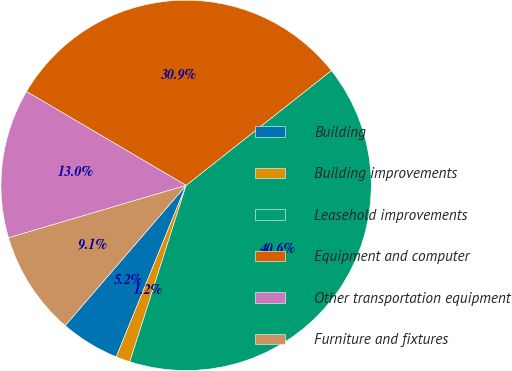Convert chart. <chart><loc_0><loc_0><loc_500><loc_500><pie_chart><fcel>Building<fcel>Building improvements<fcel>Leasehold improvements<fcel>Equipment and computer<fcel>Other transportation equipment<fcel>Furniture and fixtures<nl><fcel>5.17%<fcel>1.24%<fcel>40.56%<fcel>30.89%<fcel>13.03%<fcel>9.1%<nl></chart> 